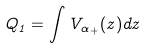Convert formula to latex. <formula><loc_0><loc_0><loc_500><loc_500>Q _ { 1 } = \int V _ { \alpha _ { + } } ( z ) d z</formula> 